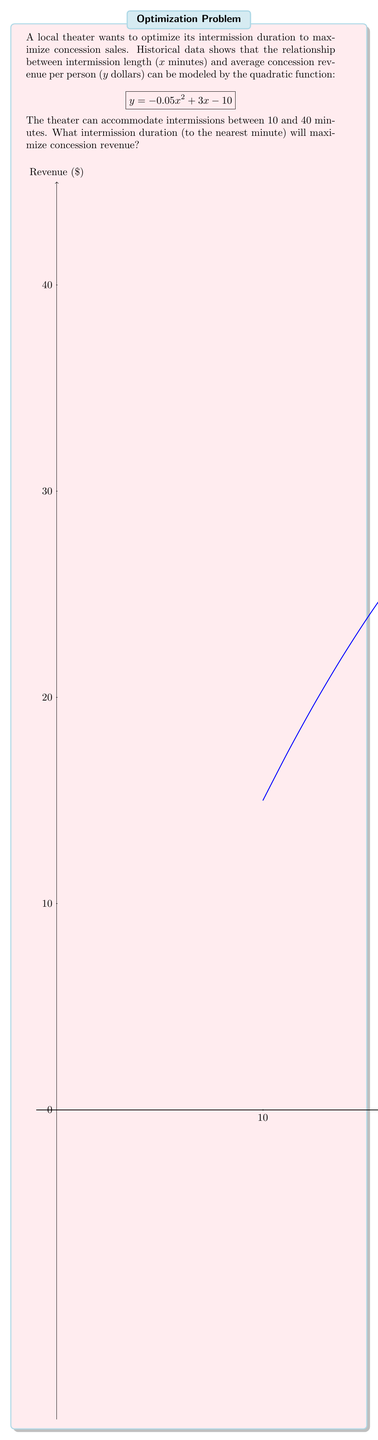What is the answer to this math problem? To find the optimal intermission duration, we need to find the maximum of the quadratic function within the given range. Let's approach this step-by-step:

1) The quadratic function is in the form $y = ax^2 + bx + c$, where:
   $a = -0.05$, $b = 3$, and $c = -10$

2) For a quadratic function, the x-coordinate of the vertex gives the maximum (when $a < 0$). The formula for this is:
   $$x = -\frac{b}{2a}$$

3) Substituting our values:
   $$x = -\frac{3}{2(-0.05)} = \frac{3}{0.1} = 30$$

4) This falls within our allowed range of 10 to 40 minutes.

5) To verify, let's check the values on either side:
   At 29 minutes: $y = -0.05(29)^2 + 3(29) - 10 = 34.95$
   At 30 minutes: $y = -0.05(30)^2 + 3(30) - 10 = 35.00$
   At 31 minutes: $y = -0.05(31)^2 + 3(31) - 10 = 34.95$

6) This confirms that 30 minutes gives the maximum revenue.
Answer: 30 minutes 